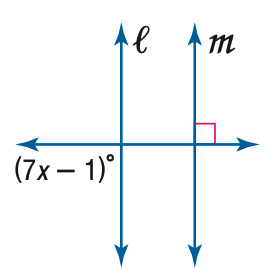Answer the mathemtical geometry problem and directly provide the correct option letter.
Question: Find x so that m \parallel n.
Choices: A: 10 B: 11 C: 12 D: 13 D 